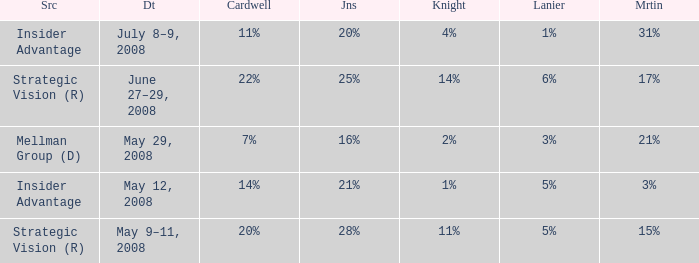What source has a Knight of 2%? Mellman Group (D). 